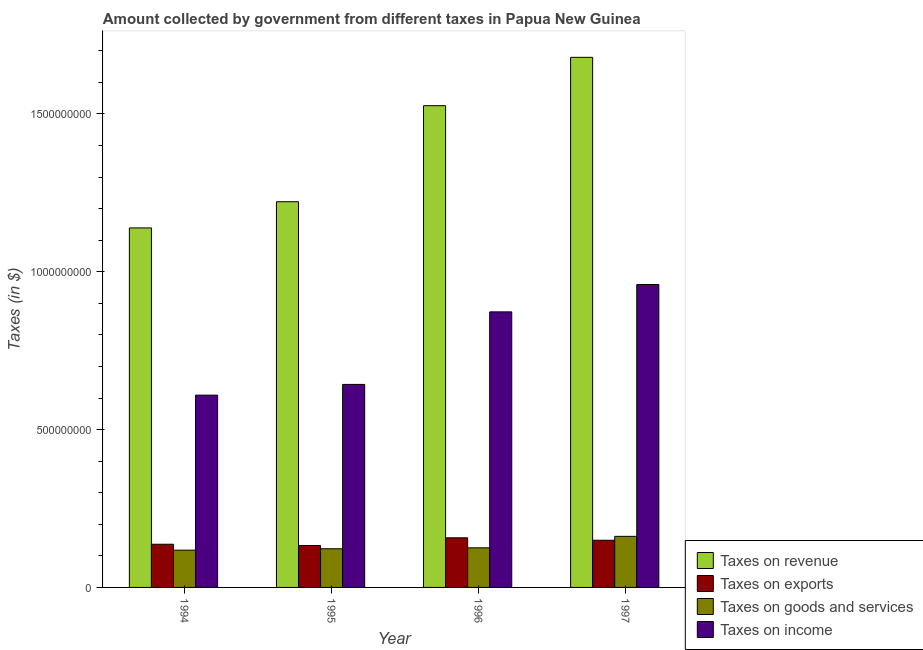Are the number of bars per tick equal to the number of legend labels?
Provide a short and direct response. Yes. How many bars are there on the 1st tick from the left?
Give a very brief answer. 4. How many bars are there on the 2nd tick from the right?
Ensure brevity in your answer.  4. What is the amount collected as tax on exports in 1997?
Offer a terse response. 1.49e+08. Across all years, what is the maximum amount collected as tax on goods?
Provide a short and direct response. 1.62e+08. Across all years, what is the minimum amount collected as tax on goods?
Offer a very short reply. 1.18e+08. What is the total amount collected as tax on income in the graph?
Offer a very short reply. 3.09e+09. What is the difference between the amount collected as tax on goods in 1996 and that in 1997?
Offer a terse response. -3.63e+07. What is the difference between the amount collected as tax on revenue in 1995 and the amount collected as tax on income in 1996?
Your answer should be compact. -3.04e+08. What is the average amount collected as tax on goods per year?
Provide a succinct answer. 1.32e+08. In the year 1997, what is the difference between the amount collected as tax on exports and amount collected as tax on revenue?
Offer a terse response. 0. What is the ratio of the amount collected as tax on revenue in 1994 to that in 1997?
Offer a terse response. 0.68. Is the amount collected as tax on goods in 1994 less than that in 1997?
Offer a terse response. Yes. What is the difference between the highest and the second highest amount collected as tax on revenue?
Provide a short and direct response. 1.53e+08. What is the difference between the highest and the lowest amount collected as tax on revenue?
Your answer should be compact. 5.40e+08. In how many years, is the amount collected as tax on exports greater than the average amount collected as tax on exports taken over all years?
Make the answer very short. 2. What does the 2nd bar from the left in 1995 represents?
Offer a very short reply. Taxes on exports. What does the 4th bar from the right in 1994 represents?
Make the answer very short. Taxes on revenue. Is it the case that in every year, the sum of the amount collected as tax on revenue and amount collected as tax on exports is greater than the amount collected as tax on goods?
Your answer should be very brief. Yes. How many bars are there?
Offer a terse response. 16. How many years are there in the graph?
Ensure brevity in your answer.  4. Are the values on the major ticks of Y-axis written in scientific E-notation?
Keep it short and to the point. No. Does the graph contain any zero values?
Offer a very short reply. No. Does the graph contain grids?
Provide a short and direct response. No. Where does the legend appear in the graph?
Offer a very short reply. Bottom right. How many legend labels are there?
Provide a short and direct response. 4. How are the legend labels stacked?
Offer a terse response. Vertical. What is the title of the graph?
Your answer should be very brief. Amount collected by government from different taxes in Papua New Guinea. What is the label or title of the X-axis?
Ensure brevity in your answer.  Year. What is the label or title of the Y-axis?
Your response must be concise. Taxes (in $). What is the Taxes (in $) in Taxes on revenue in 1994?
Give a very brief answer. 1.14e+09. What is the Taxes (in $) in Taxes on exports in 1994?
Offer a terse response. 1.37e+08. What is the Taxes (in $) in Taxes on goods and services in 1994?
Make the answer very short. 1.18e+08. What is the Taxes (in $) of Taxes on income in 1994?
Offer a very short reply. 6.09e+08. What is the Taxes (in $) of Taxes on revenue in 1995?
Ensure brevity in your answer.  1.22e+09. What is the Taxes (in $) in Taxes on exports in 1995?
Ensure brevity in your answer.  1.33e+08. What is the Taxes (in $) in Taxes on goods and services in 1995?
Offer a terse response. 1.23e+08. What is the Taxes (in $) in Taxes on income in 1995?
Your answer should be compact. 6.43e+08. What is the Taxes (in $) in Taxes on revenue in 1996?
Make the answer very short. 1.53e+09. What is the Taxes (in $) in Taxes on exports in 1996?
Offer a very short reply. 1.57e+08. What is the Taxes (in $) in Taxes on goods and services in 1996?
Offer a terse response. 1.26e+08. What is the Taxes (in $) of Taxes on income in 1996?
Keep it short and to the point. 8.73e+08. What is the Taxes (in $) in Taxes on revenue in 1997?
Provide a short and direct response. 1.68e+09. What is the Taxes (in $) of Taxes on exports in 1997?
Offer a very short reply. 1.49e+08. What is the Taxes (in $) in Taxes on goods and services in 1997?
Your response must be concise. 1.62e+08. What is the Taxes (in $) of Taxes on income in 1997?
Offer a terse response. 9.60e+08. Across all years, what is the maximum Taxes (in $) of Taxes on revenue?
Ensure brevity in your answer.  1.68e+09. Across all years, what is the maximum Taxes (in $) of Taxes on exports?
Your answer should be very brief. 1.57e+08. Across all years, what is the maximum Taxes (in $) of Taxes on goods and services?
Keep it short and to the point. 1.62e+08. Across all years, what is the maximum Taxes (in $) of Taxes on income?
Offer a terse response. 9.60e+08. Across all years, what is the minimum Taxes (in $) in Taxes on revenue?
Give a very brief answer. 1.14e+09. Across all years, what is the minimum Taxes (in $) of Taxes on exports?
Provide a short and direct response. 1.33e+08. Across all years, what is the minimum Taxes (in $) of Taxes on goods and services?
Provide a short and direct response. 1.18e+08. Across all years, what is the minimum Taxes (in $) of Taxes on income?
Keep it short and to the point. 6.09e+08. What is the total Taxes (in $) of Taxes on revenue in the graph?
Ensure brevity in your answer.  5.57e+09. What is the total Taxes (in $) of Taxes on exports in the graph?
Your answer should be compact. 5.76e+08. What is the total Taxes (in $) in Taxes on goods and services in the graph?
Offer a very short reply. 5.28e+08. What is the total Taxes (in $) in Taxes on income in the graph?
Offer a terse response. 3.09e+09. What is the difference between the Taxes (in $) in Taxes on revenue in 1994 and that in 1995?
Offer a terse response. -8.30e+07. What is the difference between the Taxes (in $) of Taxes on exports in 1994 and that in 1995?
Make the answer very short. 3.96e+06. What is the difference between the Taxes (in $) of Taxes on goods and services in 1994 and that in 1995?
Make the answer very short. -4.44e+06. What is the difference between the Taxes (in $) of Taxes on income in 1994 and that in 1995?
Keep it short and to the point. -3.40e+07. What is the difference between the Taxes (in $) in Taxes on revenue in 1994 and that in 1996?
Your response must be concise. -3.87e+08. What is the difference between the Taxes (in $) of Taxes on exports in 1994 and that in 1996?
Keep it short and to the point. -2.04e+07. What is the difference between the Taxes (in $) of Taxes on goods and services in 1994 and that in 1996?
Your answer should be compact. -7.43e+06. What is the difference between the Taxes (in $) of Taxes on income in 1994 and that in 1996?
Keep it short and to the point. -2.64e+08. What is the difference between the Taxes (in $) of Taxes on revenue in 1994 and that in 1997?
Provide a succinct answer. -5.40e+08. What is the difference between the Taxes (in $) of Taxes on exports in 1994 and that in 1997?
Ensure brevity in your answer.  -1.26e+07. What is the difference between the Taxes (in $) in Taxes on goods and services in 1994 and that in 1997?
Give a very brief answer. -4.37e+07. What is the difference between the Taxes (in $) of Taxes on income in 1994 and that in 1997?
Keep it short and to the point. -3.50e+08. What is the difference between the Taxes (in $) of Taxes on revenue in 1995 and that in 1996?
Provide a succinct answer. -3.04e+08. What is the difference between the Taxes (in $) in Taxes on exports in 1995 and that in 1996?
Make the answer very short. -2.43e+07. What is the difference between the Taxes (in $) in Taxes on goods and services in 1995 and that in 1996?
Offer a terse response. -2.99e+06. What is the difference between the Taxes (in $) of Taxes on income in 1995 and that in 1996?
Your answer should be compact. -2.30e+08. What is the difference between the Taxes (in $) of Taxes on revenue in 1995 and that in 1997?
Offer a very short reply. -4.57e+08. What is the difference between the Taxes (in $) of Taxes on exports in 1995 and that in 1997?
Give a very brief answer. -1.66e+07. What is the difference between the Taxes (in $) of Taxes on goods and services in 1995 and that in 1997?
Offer a terse response. -3.93e+07. What is the difference between the Taxes (in $) in Taxes on income in 1995 and that in 1997?
Provide a succinct answer. -3.16e+08. What is the difference between the Taxes (in $) of Taxes on revenue in 1996 and that in 1997?
Ensure brevity in your answer.  -1.53e+08. What is the difference between the Taxes (in $) of Taxes on exports in 1996 and that in 1997?
Offer a terse response. 7.74e+06. What is the difference between the Taxes (in $) in Taxes on goods and services in 1996 and that in 1997?
Your response must be concise. -3.63e+07. What is the difference between the Taxes (in $) in Taxes on income in 1996 and that in 1997?
Your answer should be very brief. -8.66e+07. What is the difference between the Taxes (in $) in Taxes on revenue in 1994 and the Taxes (in $) in Taxes on exports in 1995?
Make the answer very short. 1.01e+09. What is the difference between the Taxes (in $) in Taxes on revenue in 1994 and the Taxes (in $) in Taxes on goods and services in 1995?
Make the answer very short. 1.02e+09. What is the difference between the Taxes (in $) in Taxes on revenue in 1994 and the Taxes (in $) in Taxes on income in 1995?
Your response must be concise. 4.96e+08. What is the difference between the Taxes (in $) in Taxes on exports in 1994 and the Taxes (in $) in Taxes on goods and services in 1995?
Offer a terse response. 1.43e+07. What is the difference between the Taxes (in $) of Taxes on exports in 1994 and the Taxes (in $) of Taxes on income in 1995?
Offer a very short reply. -5.06e+08. What is the difference between the Taxes (in $) of Taxes on goods and services in 1994 and the Taxes (in $) of Taxes on income in 1995?
Offer a terse response. -5.25e+08. What is the difference between the Taxes (in $) of Taxes on revenue in 1994 and the Taxes (in $) of Taxes on exports in 1996?
Provide a succinct answer. 9.82e+08. What is the difference between the Taxes (in $) of Taxes on revenue in 1994 and the Taxes (in $) of Taxes on goods and services in 1996?
Keep it short and to the point. 1.01e+09. What is the difference between the Taxes (in $) in Taxes on revenue in 1994 and the Taxes (in $) in Taxes on income in 1996?
Offer a terse response. 2.66e+08. What is the difference between the Taxes (in $) of Taxes on exports in 1994 and the Taxes (in $) of Taxes on goods and services in 1996?
Offer a terse response. 1.13e+07. What is the difference between the Taxes (in $) of Taxes on exports in 1994 and the Taxes (in $) of Taxes on income in 1996?
Ensure brevity in your answer.  -7.36e+08. What is the difference between the Taxes (in $) of Taxes on goods and services in 1994 and the Taxes (in $) of Taxes on income in 1996?
Make the answer very short. -7.55e+08. What is the difference between the Taxes (in $) of Taxes on revenue in 1994 and the Taxes (in $) of Taxes on exports in 1997?
Your answer should be compact. 9.90e+08. What is the difference between the Taxes (in $) of Taxes on revenue in 1994 and the Taxes (in $) of Taxes on goods and services in 1997?
Your answer should be very brief. 9.77e+08. What is the difference between the Taxes (in $) of Taxes on revenue in 1994 and the Taxes (in $) of Taxes on income in 1997?
Your response must be concise. 1.79e+08. What is the difference between the Taxes (in $) of Taxes on exports in 1994 and the Taxes (in $) of Taxes on goods and services in 1997?
Provide a succinct answer. -2.50e+07. What is the difference between the Taxes (in $) in Taxes on exports in 1994 and the Taxes (in $) in Taxes on income in 1997?
Make the answer very short. -8.23e+08. What is the difference between the Taxes (in $) in Taxes on goods and services in 1994 and the Taxes (in $) in Taxes on income in 1997?
Provide a short and direct response. -8.42e+08. What is the difference between the Taxes (in $) of Taxes on revenue in 1995 and the Taxes (in $) of Taxes on exports in 1996?
Provide a short and direct response. 1.06e+09. What is the difference between the Taxes (in $) in Taxes on revenue in 1995 and the Taxes (in $) in Taxes on goods and services in 1996?
Offer a very short reply. 1.10e+09. What is the difference between the Taxes (in $) in Taxes on revenue in 1995 and the Taxes (in $) in Taxes on income in 1996?
Your response must be concise. 3.49e+08. What is the difference between the Taxes (in $) in Taxes on exports in 1995 and the Taxes (in $) in Taxes on goods and services in 1996?
Give a very brief answer. 7.35e+06. What is the difference between the Taxes (in $) in Taxes on exports in 1995 and the Taxes (in $) in Taxes on income in 1996?
Make the answer very short. -7.40e+08. What is the difference between the Taxes (in $) of Taxes on goods and services in 1995 and the Taxes (in $) of Taxes on income in 1996?
Make the answer very short. -7.51e+08. What is the difference between the Taxes (in $) in Taxes on revenue in 1995 and the Taxes (in $) in Taxes on exports in 1997?
Offer a very short reply. 1.07e+09. What is the difference between the Taxes (in $) of Taxes on revenue in 1995 and the Taxes (in $) of Taxes on goods and services in 1997?
Keep it short and to the point. 1.06e+09. What is the difference between the Taxes (in $) of Taxes on revenue in 1995 and the Taxes (in $) of Taxes on income in 1997?
Your answer should be very brief. 2.62e+08. What is the difference between the Taxes (in $) in Taxes on exports in 1995 and the Taxes (in $) in Taxes on goods and services in 1997?
Offer a very short reply. -2.89e+07. What is the difference between the Taxes (in $) of Taxes on exports in 1995 and the Taxes (in $) of Taxes on income in 1997?
Provide a succinct answer. -8.27e+08. What is the difference between the Taxes (in $) of Taxes on goods and services in 1995 and the Taxes (in $) of Taxes on income in 1997?
Give a very brief answer. -8.37e+08. What is the difference between the Taxes (in $) of Taxes on revenue in 1996 and the Taxes (in $) of Taxes on exports in 1997?
Give a very brief answer. 1.38e+09. What is the difference between the Taxes (in $) of Taxes on revenue in 1996 and the Taxes (in $) of Taxes on goods and services in 1997?
Keep it short and to the point. 1.36e+09. What is the difference between the Taxes (in $) in Taxes on revenue in 1996 and the Taxes (in $) in Taxes on income in 1997?
Make the answer very short. 5.67e+08. What is the difference between the Taxes (in $) of Taxes on exports in 1996 and the Taxes (in $) of Taxes on goods and services in 1997?
Your response must be concise. -4.61e+06. What is the difference between the Taxes (in $) in Taxes on exports in 1996 and the Taxes (in $) in Taxes on income in 1997?
Make the answer very short. -8.02e+08. What is the difference between the Taxes (in $) in Taxes on goods and services in 1996 and the Taxes (in $) in Taxes on income in 1997?
Your response must be concise. -8.34e+08. What is the average Taxes (in $) of Taxes on revenue per year?
Provide a succinct answer. 1.39e+09. What is the average Taxes (in $) in Taxes on exports per year?
Keep it short and to the point. 1.44e+08. What is the average Taxes (in $) in Taxes on goods and services per year?
Keep it short and to the point. 1.32e+08. What is the average Taxes (in $) of Taxes on income per year?
Your answer should be compact. 7.71e+08. In the year 1994, what is the difference between the Taxes (in $) of Taxes on revenue and Taxes (in $) of Taxes on exports?
Your answer should be very brief. 1.00e+09. In the year 1994, what is the difference between the Taxes (in $) of Taxes on revenue and Taxes (in $) of Taxes on goods and services?
Ensure brevity in your answer.  1.02e+09. In the year 1994, what is the difference between the Taxes (in $) in Taxes on revenue and Taxes (in $) in Taxes on income?
Keep it short and to the point. 5.30e+08. In the year 1994, what is the difference between the Taxes (in $) of Taxes on exports and Taxes (in $) of Taxes on goods and services?
Your response must be concise. 1.87e+07. In the year 1994, what is the difference between the Taxes (in $) in Taxes on exports and Taxes (in $) in Taxes on income?
Give a very brief answer. -4.72e+08. In the year 1994, what is the difference between the Taxes (in $) in Taxes on goods and services and Taxes (in $) in Taxes on income?
Make the answer very short. -4.91e+08. In the year 1995, what is the difference between the Taxes (in $) of Taxes on revenue and Taxes (in $) of Taxes on exports?
Offer a very short reply. 1.09e+09. In the year 1995, what is the difference between the Taxes (in $) in Taxes on revenue and Taxes (in $) in Taxes on goods and services?
Your answer should be compact. 1.10e+09. In the year 1995, what is the difference between the Taxes (in $) of Taxes on revenue and Taxes (in $) of Taxes on income?
Provide a short and direct response. 5.79e+08. In the year 1995, what is the difference between the Taxes (in $) in Taxes on exports and Taxes (in $) in Taxes on goods and services?
Your answer should be very brief. 1.03e+07. In the year 1995, what is the difference between the Taxes (in $) in Taxes on exports and Taxes (in $) in Taxes on income?
Your answer should be very brief. -5.10e+08. In the year 1995, what is the difference between the Taxes (in $) in Taxes on goods and services and Taxes (in $) in Taxes on income?
Make the answer very short. -5.21e+08. In the year 1996, what is the difference between the Taxes (in $) in Taxes on revenue and Taxes (in $) in Taxes on exports?
Make the answer very short. 1.37e+09. In the year 1996, what is the difference between the Taxes (in $) of Taxes on revenue and Taxes (in $) of Taxes on goods and services?
Ensure brevity in your answer.  1.40e+09. In the year 1996, what is the difference between the Taxes (in $) of Taxes on revenue and Taxes (in $) of Taxes on income?
Provide a short and direct response. 6.53e+08. In the year 1996, what is the difference between the Taxes (in $) of Taxes on exports and Taxes (in $) of Taxes on goods and services?
Make the answer very short. 3.17e+07. In the year 1996, what is the difference between the Taxes (in $) in Taxes on exports and Taxes (in $) in Taxes on income?
Offer a terse response. -7.16e+08. In the year 1996, what is the difference between the Taxes (in $) in Taxes on goods and services and Taxes (in $) in Taxes on income?
Provide a succinct answer. -7.48e+08. In the year 1997, what is the difference between the Taxes (in $) in Taxes on revenue and Taxes (in $) in Taxes on exports?
Ensure brevity in your answer.  1.53e+09. In the year 1997, what is the difference between the Taxes (in $) in Taxes on revenue and Taxes (in $) in Taxes on goods and services?
Ensure brevity in your answer.  1.52e+09. In the year 1997, what is the difference between the Taxes (in $) in Taxes on revenue and Taxes (in $) in Taxes on income?
Offer a terse response. 7.20e+08. In the year 1997, what is the difference between the Taxes (in $) of Taxes on exports and Taxes (in $) of Taxes on goods and services?
Your response must be concise. -1.24e+07. In the year 1997, what is the difference between the Taxes (in $) in Taxes on exports and Taxes (in $) in Taxes on income?
Your answer should be compact. -8.10e+08. In the year 1997, what is the difference between the Taxes (in $) of Taxes on goods and services and Taxes (in $) of Taxes on income?
Ensure brevity in your answer.  -7.98e+08. What is the ratio of the Taxes (in $) in Taxes on revenue in 1994 to that in 1995?
Offer a very short reply. 0.93. What is the ratio of the Taxes (in $) of Taxes on exports in 1994 to that in 1995?
Provide a succinct answer. 1.03. What is the ratio of the Taxes (in $) in Taxes on goods and services in 1994 to that in 1995?
Make the answer very short. 0.96. What is the ratio of the Taxes (in $) in Taxes on income in 1994 to that in 1995?
Keep it short and to the point. 0.95. What is the ratio of the Taxes (in $) of Taxes on revenue in 1994 to that in 1996?
Your answer should be compact. 0.75. What is the ratio of the Taxes (in $) of Taxes on exports in 1994 to that in 1996?
Your response must be concise. 0.87. What is the ratio of the Taxes (in $) in Taxes on goods and services in 1994 to that in 1996?
Your response must be concise. 0.94. What is the ratio of the Taxes (in $) of Taxes on income in 1994 to that in 1996?
Offer a very short reply. 0.7. What is the ratio of the Taxes (in $) in Taxes on revenue in 1994 to that in 1997?
Your response must be concise. 0.68. What is the ratio of the Taxes (in $) in Taxes on exports in 1994 to that in 1997?
Make the answer very short. 0.92. What is the ratio of the Taxes (in $) of Taxes on goods and services in 1994 to that in 1997?
Your response must be concise. 0.73. What is the ratio of the Taxes (in $) in Taxes on income in 1994 to that in 1997?
Provide a short and direct response. 0.63. What is the ratio of the Taxes (in $) of Taxes on revenue in 1995 to that in 1996?
Offer a terse response. 0.8. What is the ratio of the Taxes (in $) in Taxes on exports in 1995 to that in 1996?
Give a very brief answer. 0.85. What is the ratio of the Taxes (in $) in Taxes on goods and services in 1995 to that in 1996?
Provide a short and direct response. 0.98. What is the ratio of the Taxes (in $) in Taxes on income in 1995 to that in 1996?
Keep it short and to the point. 0.74. What is the ratio of the Taxes (in $) in Taxes on revenue in 1995 to that in 1997?
Make the answer very short. 0.73. What is the ratio of the Taxes (in $) in Taxes on exports in 1995 to that in 1997?
Your answer should be very brief. 0.89. What is the ratio of the Taxes (in $) of Taxes on goods and services in 1995 to that in 1997?
Your response must be concise. 0.76. What is the ratio of the Taxes (in $) in Taxes on income in 1995 to that in 1997?
Provide a succinct answer. 0.67. What is the ratio of the Taxes (in $) of Taxes on revenue in 1996 to that in 1997?
Provide a short and direct response. 0.91. What is the ratio of the Taxes (in $) in Taxes on exports in 1996 to that in 1997?
Your answer should be very brief. 1.05. What is the ratio of the Taxes (in $) in Taxes on goods and services in 1996 to that in 1997?
Ensure brevity in your answer.  0.78. What is the ratio of the Taxes (in $) of Taxes on income in 1996 to that in 1997?
Your answer should be very brief. 0.91. What is the difference between the highest and the second highest Taxes (in $) in Taxes on revenue?
Keep it short and to the point. 1.53e+08. What is the difference between the highest and the second highest Taxes (in $) in Taxes on exports?
Your response must be concise. 7.74e+06. What is the difference between the highest and the second highest Taxes (in $) in Taxes on goods and services?
Keep it short and to the point. 3.63e+07. What is the difference between the highest and the second highest Taxes (in $) of Taxes on income?
Offer a terse response. 8.66e+07. What is the difference between the highest and the lowest Taxes (in $) of Taxes on revenue?
Offer a terse response. 5.40e+08. What is the difference between the highest and the lowest Taxes (in $) in Taxes on exports?
Make the answer very short. 2.43e+07. What is the difference between the highest and the lowest Taxes (in $) of Taxes on goods and services?
Your answer should be compact. 4.37e+07. What is the difference between the highest and the lowest Taxes (in $) of Taxes on income?
Ensure brevity in your answer.  3.50e+08. 